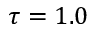<formula> <loc_0><loc_0><loc_500><loc_500>\tau = 1 . 0</formula> 